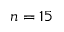<formula> <loc_0><loc_0><loc_500><loc_500>n = 1 5</formula> 